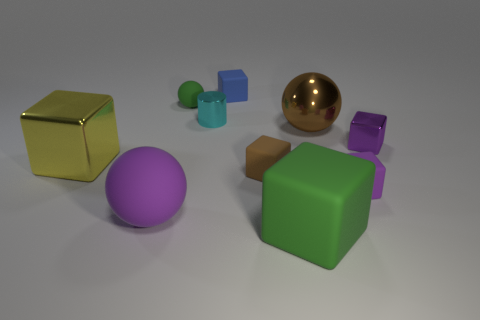Subtract all yellow blocks. How many blocks are left? 5 Subtract all purple metal blocks. How many blocks are left? 5 Subtract all gray cubes. Subtract all cyan cylinders. How many cubes are left? 6 Subtract all blocks. How many objects are left? 4 Add 4 large matte cubes. How many large matte cubes are left? 5 Add 6 tiny cyan balls. How many tiny cyan balls exist? 6 Subtract 0 yellow spheres. How many objects are left? 10 Subtract all small brown spheres. Subtract all blue rubber objects. How many objects are left? 9 